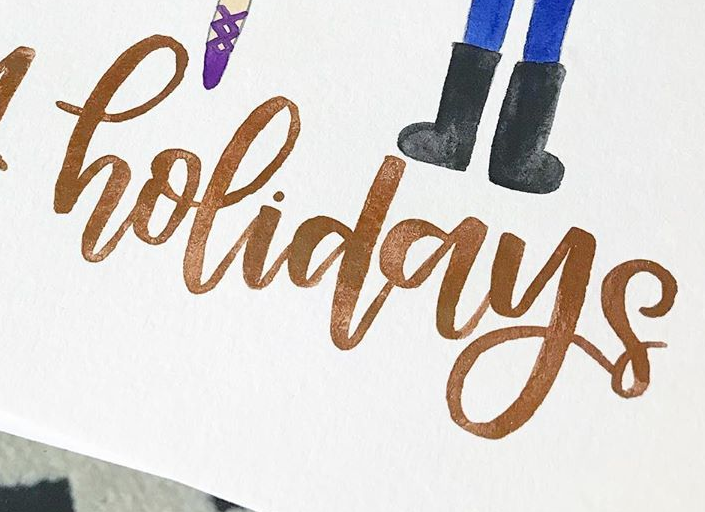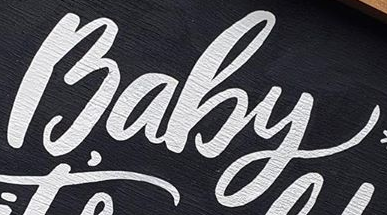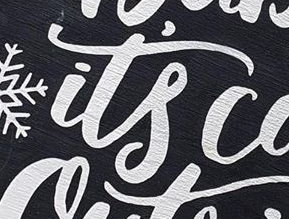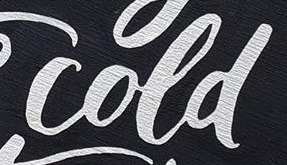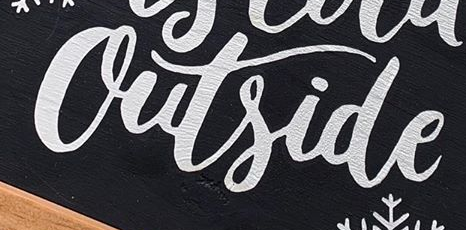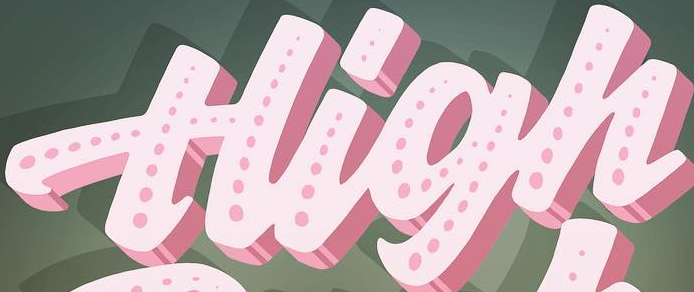Read the text from these images in sequence, separated by a semicolon. holidays; Baby; it's; cold; Outside; High 